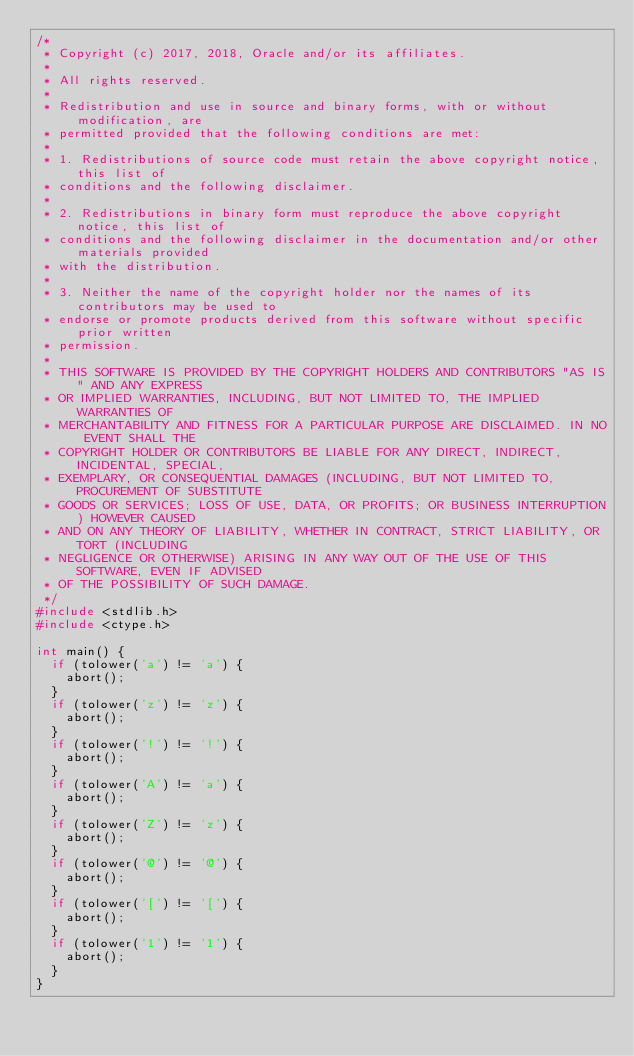Convert code to text. <code><loc_0><loc_0><loc_500><loc_500><_C_>/*
 * Copyright (c) 2017, 2018, Oracle and/or its affiliates.
 *
 * All rights reserved.
 *
 * Redistribution and use in source and binary forms, with or without modification, are
 * permitted provided that the following conditions are met:
 *
 * 1. Redistributions of source code must retain the above copyright notice, this list of
 * conditions and the following disclaimer.
 *
 * 2. Redistributions in binary form must reproduce the above copyright notice, this list of
 * conditions and the following disclaimer in the documentation and/or other materials provided
 * with the distribution.
 *
 * 3. Neither the name of the copyright holder nor the names of its contributors may be used to
 * endorse or promote products derived from this software without specific prior written
 * permission.
 *
 * THIS SOFTWARE IS PROVIDED BY THE COPYRIGHT HOLDERS AND CONTRIBUTORS "AS IS" AND ANY EXPRESS
 * OR IMPLIED WARRANTIES, INCLUDING, BUT NOT LIMITED TO, THE IMPLIED WARRANTIES OF
 * MERCHANTABILITY AND FITNESS FOR A PARTICULAR PURPOSE ARE DISCLAIMED. IN NO EVENT SHALL THE
 * COPYRIGHT HOLDER OR CONTRIBUTORS BE LIABLE FOR ANY DIRECT, INDIRECT, INCIDENTAL, SPECIAL,
 * EXEMPLARY, OR CONSEQUENTIAL DAMAGES (INCLUDING, BUT NOT LIMITED TO, PROCUREMENT OF SUBSTITUTE
 * GOODS OR SERVICES; LOSS OF USE, DATA, OR PROFITS; OR BUSINESS INTERRUPTION) HOWEVER CAUSED
 * AND ON ANY THEORY OF LIABILITY, WHETHER IN CONTRACT, STRICT LIABILITY, OR TORT (INCLUDING
 * NEGLIGENCE OR OTHERWISE) ARISING IN ANY WAY OUT OF THE USE OF THIS SOFTWARE, EVEN IF ADVISED
 * OF THE POSSIBILITY OF SUCH DAMAGE.
 */
#include <stdlib.h>
#include <ctype.h>

int main() {
  if (tolower('a') != 'a') {
    abort();
  }
  if (tolower('z') != 'z') {
    abort();
  }
  if (tolower('!') != '!') {
    abort();
  }
  if (tolower('A') != 'a') {
    abort();
  }
  if (tolower('Z') != 'z') {
    abort();
  }
  if (tolower('@') != '@') {
    abort();
  }
  if (tolower('[') != '[') {
    abort();
  }
  if (tolower('1') != '1') {
    abort();
  }
}
</code> 